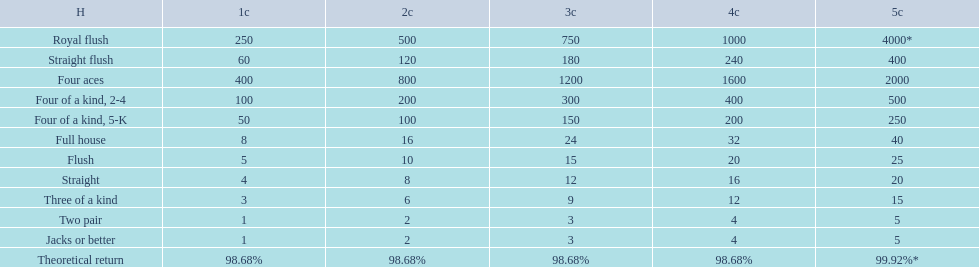What are the top 5 best types of hand for winning? Royal flush, Straight flush, Four aces, Four of a kind, 2-4, Four of a kind, 5-K. Between those 5, which of those hands are four of a kind? Four of a kind, 2-4, Four of a kind, 5-K. Would you be able to parse every entry in this table? {'header': ['H', '1c', '2c', '3c', '4c', '5c'], 'rows': [['Royal flush', '250', '500', '750', '1000', '4000*'], ['Straight flush', '60', '120', '180', '240', '400'], ['Four aces', '400', '800', '1200', '1600', '2000'], ['Four of a kind, 2-4', '100', '200', '300', '400', '500'], ['Four of a kind, 5-K', '50', '100', '150', '200', '250'], ['Full house', '8', '16', '24', '32', '40'], ['Flush', '5', '10', '15', '20', '25'], ['Straight', '4', '8', '12', '16', '20'], ['Three of a kind', '3', '6', '9', '12', '15'], ['Two pair', '1', '2', '3', '4', '5'], ['Jacks or better', '1', '2', '3', '4', '5'], ['Theoretical return', '98.68%', '98.68%', '98.68%', '98.68%', '99.92%*']]} Of those 2 hands, which is the best kind of four of a kind for winning? Four of a kind, 2-4. 